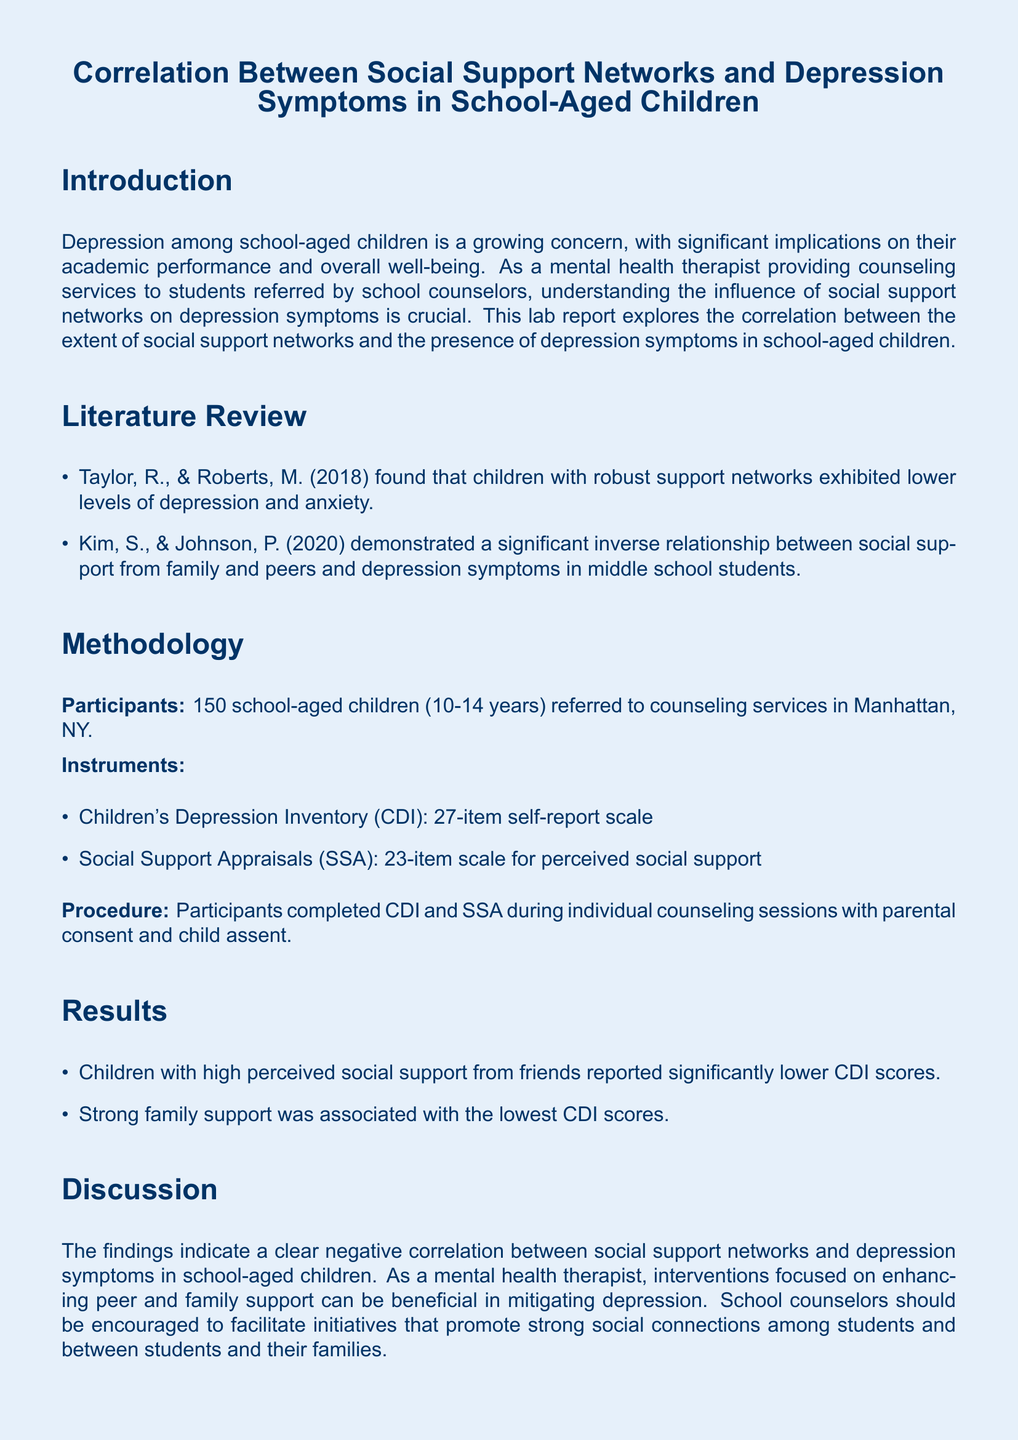What is the main focus of this lab report? The lab report explores the correlation between social support networks and depression symptoms in school-aged children.
Answer: Correlation between social support networks and depression symptoms How many participants were involved in the study? The number of participants is stated in the methodology section of the document.
Answer: 150 Which instruments were used to assess depression? The document lists the instruments used for the study, including the Children's Depression Inventory.
Answer: Children's Depression Inventory What age range did the participants fall into? The age range is specified in the participant section of the methodology.
Answer: 10-14 years What was a key finding regarding social support from friends? The results section states the relationship between social support from friends and depression symptoms.
Answer: Significantly lower CDI scores Which type of support was associated with the lowest CDI scores? The results section indicates which type of support had the most significant effect on CDI scores.
Answer: Strong family support Who are the authors of the references provided? The literature review section lists the authors of the studies reviewed.
Answer: Taylor, R., and Roberts, M What is a recommendation for school counselors based on the findings? The discussion section provides recommendations for school counselors concerning social support networks.
Answer: Facilitate initiatives that promote strong social connections 